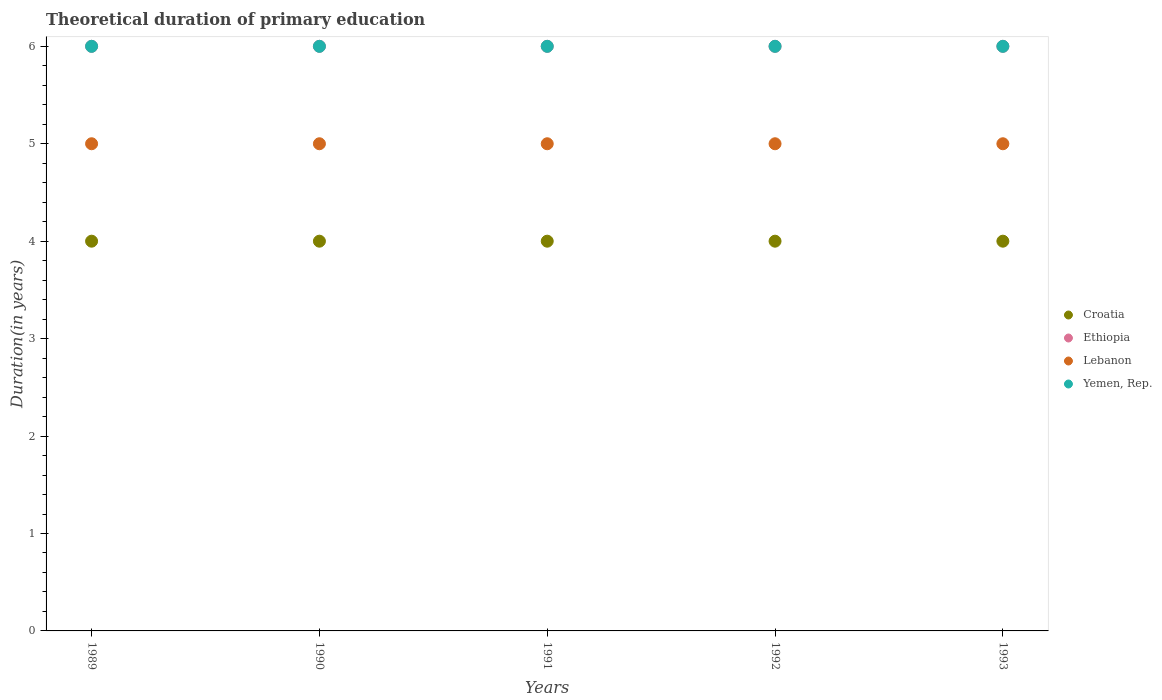Is the number of dotlines equal to the number of legend labels?
Give a very brief answer. Yes. What is the total theoretical duration of primary education in Yemen, Rep. in 1989?
Your answer should be very brief. 6. Across all years, what is the maximum total theoretical duration of primary education in Croatia?
Make the answer very short. 4. Across all years, what is the minimum total theoretical duration of primary education in Croatia?
Give a very brief answer. 4. In which year was the total theoretical duration of primary education in Yemen, Rep. maximum?
Keep it short and to the point. 1989. In which year was the total theoretical duration of primary education in Croatia minimum?
Your answer should be compact. 1989. What is the total total theoretical duration of primary education in Lebanon in the graph?
Offer a terse response. 25. What is the difference between the total theoretical duration of primary education in Yemen, Rep. in 1993 and the total theoretical duration of primary education in Lebanon in 1990?
Give a very brief answer. 1. What is the average total theoretical duration of primary education in Croatia per year?
Offer a terse response. 4. In the year 1993, what is the difference between the total theoretical duration of primary education in Lebanon and total theoretical duration of primary education in Yemen, Rep.?
Make the answer very short. -1. In how many years, is the total theoretical duration of primary education in Lebanon greater than 5.8 years?
Ensure brevity in your answer.  0. Is the total theoretical duration of primary education in Ethiopia in 1990 less than that in 1993?
Keep it short and to the point. No. What is the difference between the highest and the lowest total theoretical duration of primary education in Croatia?
Offer a terse response. 0. In how many years, is the total theoretical duration of primary education in Lebanon greater than the average total theoretical duration of primary education in Lebanon taken over all years?
Ensure brevity in your answer.  0. Does the total theoretical duration of primary education in Lebanon monotonically increase over the years?
Your response must be concise. No. Is the total theoretical duration of primary education in Yemen, Rep. strictly less than the total theoretical duration of primary education in Ethiopia over the years?
Provide a succinct answer. No. How many years are there in the graph?
Provide a succinct answer. 5. What is the difference between two consecutive major ticks on the Y-axis?
Your response must be concise. 1. Are the values on the major ticks of Y-axis written in scientific E-notation?
Ensure brevity in your answer.  No. Does the graph contain any zero values?
Your answer should be very brief. No. Where does the legend appear in the graph?
Your answer should be very brief. Center right. How many legend labels are there?
Offer a very short reply. 4. How are the legend labels stacked?
Ensure brevity in your answer.  Vertical. What is the title of the graph?
Your answer should be very brief. Theoretical duration of primary education. Does "High income" appear as one of the legend labels in the graph?
Your response must be concise. No. What is the label or title of the Y-axis?
Offer a terse response. Duration(in years). What is the Duration(in years) in Croatia in 1989?
Your answer should be very brief. 4. What is the Duration(in years) of Lebanon in 1989?
Provide a succinct answer. 5. What is the Duration(in years) of Yemen, Rep. in 1989?
Your answer should be compact. 6. What is the Duration(in years) in Croatia in 1990?
Make the answer very short. 4. What is the Duration(in years) of Lebanon in 1990?
Offer a terse response. 5. What is the Duration(in years) in Croatia in 1991?
Your answer should be compact. 4. What is the Duration(in years) in Yemen, Rep. in 1991?
Your answer should be very brief. 6. What is the Duration(in years) of Croatia in 1992?
Offer a very short reply. 4. What is the Duration(in years) in Lebanon in 1992?
Provide a succinct answer. 5. What is the Duration(in years) of Ethiopia in 1993?
Provide a succinct answer. 6. What is the Duration(in years) of Lebanon in 1993?
Give a very brief answer. 5. What is the Duration(in years) of Yemen, Rep. in 1993?
Offer a terse response. 6. Across all years, what is the minimum Duration(in years) in Lebanon?
Make the answer very short. 5. Across all years, what is the minimum Duration(in years) in Yemen, Rep.?
Keep it short and to the point. 6. What is the total Duration(in years) in Croatia in the graph?
Your answer should be compact. 20. What is the total Duration(in years) of Lebanon in the graph?
Your response must be concise. 25. What is the total Duration(in years) in Yemen, Rep. in the graph?
Your response must be concise. 30. What is the difference between the Duration(in years) in Yemen, Rep. in 1989 and that in 1990?
Ensure brevity in your answer.  0. What is the difference between the Duration(in years) in Lebanon in 1989 and that in 1991?
Make the answer very short. 0. What is the difference between the Duration(in years) in Yemen, Rep. in 1989 and that in 1991?
Your answer should be compact. 0. What is the difference between the Duration(in years) of Lebanon in 1989 and that in 1992?
Keep it short and to the point. 0. What is the difference between the Duration(in years) in Yemen, Rep. in 1989 and that in 1992?
Make the answer very short. 0. What is the difference between the Duration(in years) of Croatia in 1989 and that in 1993?
Provide a succinct answer. 0. What is the difference between the Duration(in years) of Yemen, Rep. in 1989 and that in 1993?
Your response must be concise. 0. What is the difference between the Duration(in years) of Croatia in 1990 and that in 1992?
Offer a terse response. 0. What is the difference between the Duration(in years) in Lebanon in 1990 and that in 1992?
Provide a short and direct response. 0. What is the difference between the Duration(in years) of Ethiopia in 1990 and that in 1993?
Give a very brief answer. 0. What is the difference between the Duration(in years) in Croatia in 1991 and that in 1993?
Make the answer very short. 0. What is the difference between the Duration(in years) of Croatia in 1992 and that in 1993?
Offer a very short reply. 0. What is the difference between the Duration(in years) of Croatia in 1989 and the Duration(in years) of Yemen, Rep. in 1990?
Your answer should be compact. -2. What is the difference between the Duration(in years) in Ethiopia in 1989 and the Duration(in years) in Lebanon in 1990?
Offer a very short reply. 1. What is the difference between the Duration(in years) in Lebanon in 1989 and the Duration(in years) in Yemen, Rep. in 1990?
Your answer should be compact. -1. What is the difference between the Duration(in years) in Croatia in 1989 and the Duration(in years) in Ethiopia in 1991?
Provide a succinct answer. -2. What is the difference between the Duration(in years) of Croatia in 1989 and the Duration(in years) of Yemen, Rep. in 1991?
Provide a short and direct response. -2. What is the difference between the Duration(in years) of Ethiopia in 1989 and the Duration(in years) of Lebanon in 1991?
Your answer should be compact. 1. What is the difference between the Duration(in years) of Lebanon in 1989 and the Duration(in years) of Yemen, Rep. in 1991?
Provide a short and direct response. -1. What is the difference between the Duration(in years) in Croatia in 1989 and the Duration(in years) in Yemen, Rep. in 1992?
Ensure brevity in your answer.  -2. What is the difference between the Duration(in years) of Ethiopia in 1989 and the Duration(in years) of Lebanon in 1992?
Provide a succinct answer. 1. What is the difference between the Duration(in years) in Ethiopia in 1989 and the Duration(in years) in Yemen, Rep. in 1992?
Your response must be concise. 0. What is the difference between the Duration(in years) of Croatia in 1989 and the Duration(in years) of Lebanon in 1993?
Ensure brevity in your answer.  -1. What is the difference between the Duration(in years) of Ethiopia in 1989 and the Duration(in years) of Yemen, Rep. in 1993?
Your response must be concise. 0. What is the difference between the Duration(in years) in Croatia in 1990 and the Duration(in years) in Ethiopia in 1991?
Ensure brevity in your answer.  -2. What is the difference between the Duration(in years) of Croatia in 1990 and the Duration(in years) of Yemen, Rep. in 1991?
Offer a very short reply. -2. What is the difference between the Duration(in years) of Ethiopia in 1990 and the Duration(in years) of Lebanon in 1991?
Offer a terse response. 1. What is the difference between the Duration(in years) of Ethiopia in 1990 and the Duration(in years) of Yemen, Rep. in 1991?
Ensure brevity in your answer.  0. What is the difference between the Duration(in years) of Lebanon in 1990 and the Duration(in years) of Yemen, Rep. in 1991?
Make the answer very short. -1. What is the difference between the Duration(in years) in Croatia in 1990 and the Duration(in years) in Ethiopia in 1992?
Offer a very short reply. -2. What is the difference between the Duration(in years) in Croatia in 1990 and the Duration(in years) in Lebanon in 1992?
Your response must be concise. -1. What is the difference between the Duration(in years) of Croatia in 1990 and the Duration(in years) of Yemen, Rep. in 1992?
Make the answer very short. -2. What is the difference between the Duration(in years) of Croatia in 1990 and the Duration(in years) of Ethiopia in 1993?
Make the answer very short. -2. What is the difference between the Duration(in years) of Croatia in 1990 and the Duration(in years) of Yemen, Rep. in 1993?
Give a very brief answer. -2. What is the difference between the Duration(in years) of Ethiopia in 1990 and the Duration(in years) of Yemen, Rep. in 1993?
Provide a succinct answer. 0. What is the difference between the Duration(in years) of Lebanon in 1990 and the Duration(in years) of Yemen, Rep. in 1993?
Your answer should be compact. -1. What is the difference between the Duration(in years) in Croatia in 1991 and the Duration(in years) in Ethiopia in 1992?
Offer a terse response. -2. What is the difference between the Duration(in years) in Ethiopia in 1991 and the Duration(in years) in Yemen, Rep. in 1992?
Offer a terse response. 0. What is the difference between the Duration(in years) in Croatia in 1991 and the Duration(in years) in Yemen, Rep. in 1993?
Provide a succinct answer. -2. What is the difference between the Duration(in years) in Ethiopia in 1991 and the Duration(in years) in Lebanon in 1993?
Your answer should be very brief. 1. What is the difference between the Duration(in years) of Ethiopia in 1991 and the Duration(in years) of Yemen, Rep. in 1993?
Offer a terse response. 0. What is the difference between the Duration(in years) in Lebanon in 1991 and the Duration(in years) in Yemen, Rep. in 1993?
Keep it short and to the point. -1. What is the difference between the Duration(in years) in Ethiopia in 1992 and the Duration(in years) in Lebanon in 1993?
Give a very brief answer. 1. What is the difference between the Duration(in years) in Lebanon in 1992 and the Duration(in years) in Yemen, Rep. in 1993?
Provide a succinct answer. -1. What is the average Duration(in years) in Croatia per year?
Offer a very short reply. 4. What is the average Duration(in years) of Ethiopia per year?
Your answer should be very brief. 6. In the year 1989, what is the difference between the Duration(in years) in Croatia and Duration(in years) in Yemen, Rep.?
Provide a short and direct response. -2. In the year 1990, what is the difference between the Duration(in years) in Croatia and Duration(in years) in Lebanon?
Provide a short and direct response. -1. In the year 1990, what is the difference between the Duration(in years) in Ethiopia and Duration(in years) in Lebanon?
Keep it short and to the point. 1. In the year 1990, what is the difference between the Duration(in years) in Ethiopia and Duration(in years) in Yemen, Rep.?
Ensure brevity in your answer.  0. In the year 1990, what is the difference between the Duration(in years) of Lebanon and Duration(in years) of Yemen, Rep.?
Offer a very short reply. -1. In the year 1991, what is the difference between the Duration(in years) in Croatia and Duration(in years) in Ethiopia?
Ensure brevity in your answer.  -2. In the year 1991, what is the difference between the Duration(in years) in Ethiopia and Duration(in years) in Lebanon?
Keep it short and to the point. 1. In the year 1992, what is the difference between the Duration(in years) in Croatia and Duration(in years) in Ethiopia?
Make the answer very short. -2. In the year 1992, what is the difference between the Duration(in years) of Croatia and Duration(in years) of Yemen, Rep.?
Provide a succinct answer. -2. In the year 1993, what is the difference between the Duration(in years) of Croatia and Duration(in years) of Ethiopia?
Your answer should be very brief. -2. In the year 1993, what is the difference between the Duration(in years) of Croatia and Duration(in years) of Yemen, Rep.?
Your answer should be compact. -2. In the year 1993, what is the difference between the Duration(in years) of Ethiopia and Duration(in years) of Lebanon?
Your answer should be compact. 1. What is the ratio of the Duration(in years) in Ethiopia in 1989 to that in 1990?
Your response must be concise. 1. What is the ratio of the Duration(in years) in Lebanon in 1989 to that in 1990?
Keep it short and to the point. 1. What is the ratio of the Duration(in years) in Croatia in 1989 to that in 1991?
Ensure brevity in your answer.  1. What is the ratio of the Duration(in years) of Lebanon in 1989 to that in 1991?
Give a very brief answer. 1. What is the ratio of the Duration(in years) of Yemen, Rep. in 1989 to that in 1991?
Offer a very short reply. 1. What is the ratio of the Duration(in years) in Ethiopia in 1989 to that in 1992?
Your response must be concise. 1. What is the ratio of the Duration(in years) in Ethiopia in 1989 to that in 1993?
Offer a terse response. 1. What is the ratio of the Duration(in years) in Lebanon in 1989 to that in 1993?
Provide a short and direct response. 1. What is the ratio of the Duration(in years) of Croatia in 1990 to that in 1991?
Offer a terse response. 1. What is the ratio of the Duration(in years) of Lebanon in 1990 to that in 1991?
Your answer should be very brief. 1. What is the ratio of the Duration(in years) in Yemen, Rep. in 1990 to that in 1991?
Your answer should be very brief. 1. What is the ratio of the Duration(in years) of Croatia in 1990 to that in 1992?
Ensure brevity in your answer.  1. What is the ratio of the Duration(in years) of Ethiopia in 1990 to that in 1992?
Your response must be concise. 1. What is the ratio of the Duration(in years) in Yemen, Rep. in 1990 to that in 1992?
Ensure brevity in your answer.  1. What is the ratio of the Duration(in years) of Croatia in 1990 to that in 1993?
Make the answer very short. 1. What is the ratio of the Duration(in years) in Yemen, Rep. in 1990 to that in 1993?
Ensure brevity in your answer.  1. What is the ratio of the Duration(in years) of Ethiopia in 1991 to that in 1992?
Provide a succinct answer. 1. What is the ratio of the Duration(in years) of Ethiopia in 1992 to that in 1993?
Make the answer very short. 1. What is the ratio of the Duration(in years) in Lebanon in 1992 to that in 1993?
Provide a short and direct response. 1. What is the ratio of the Duration(in years) of Yemen, Rep. in 1992 to that in 1993?
Give a very brief answer. 1. What is the difference between the highest and the second highest Duration(in years) of Croatia?
Keep it short and to the point. 0. What is the difference between the highest and the second highest Duration(in years) in Yemen, Rep.?
Your answer should be compact. 0. What is the difference between the highest and the lowest Duration(in years) in Ethiopia?
Give a very brief answer. 0. What is the difference between the highest and the lowest Duration(in years) of Lebanon?
Offer a terse response. 0. What is the difference between the highest and the lowest Duration(in years) of Yemen, Rep.?
Make the answer very short. 0. 